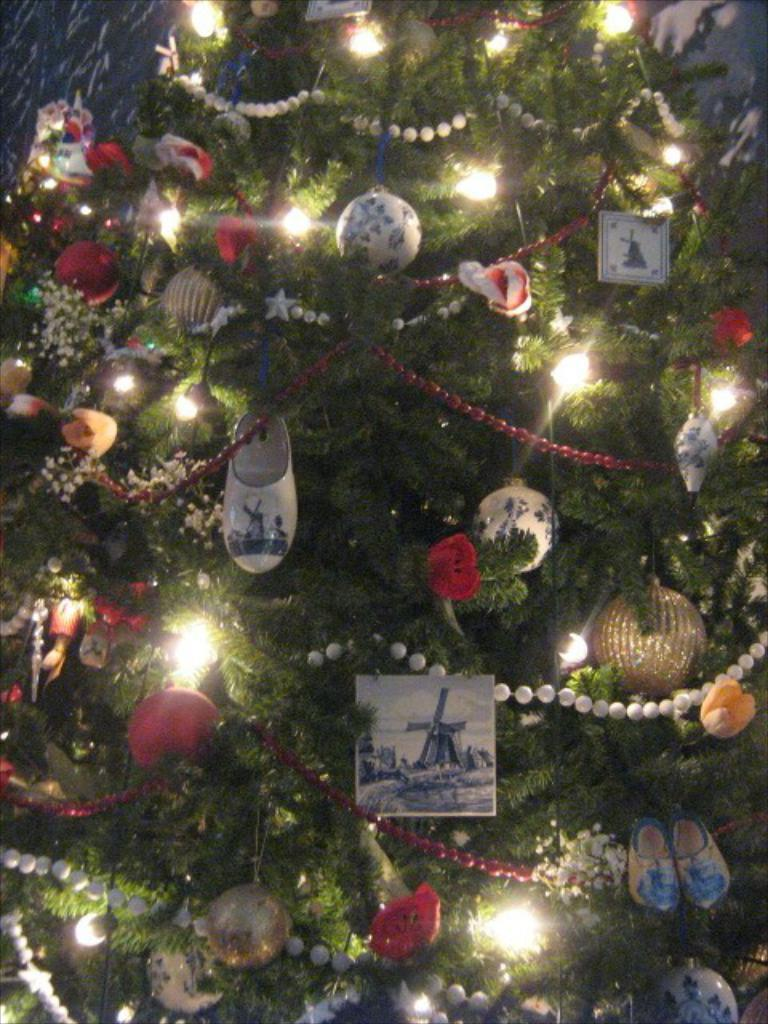What is the main object in the image? There is a Christmas tree in the image. What is on the Christmas tree? The Christmas tree has toys on it. What type of poison is dripping from the Christmas tree in the image? There is no poison present in the image; it features a Christmas tree with toys on it. What color is the shirt worn by the person behind the Christmas tree? There is no person or shirt visible in the image; it only shows a Christmas tree with toys on it. 